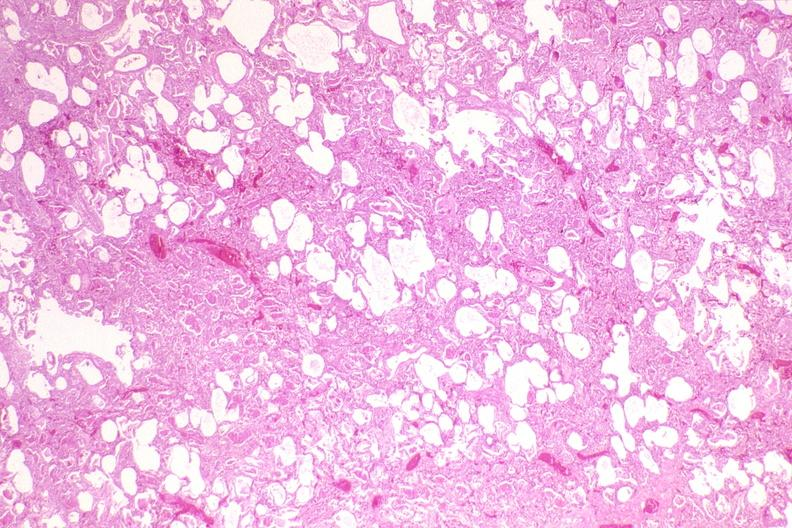what does this image show?
Answer the question using a single word or phrase. Lung 